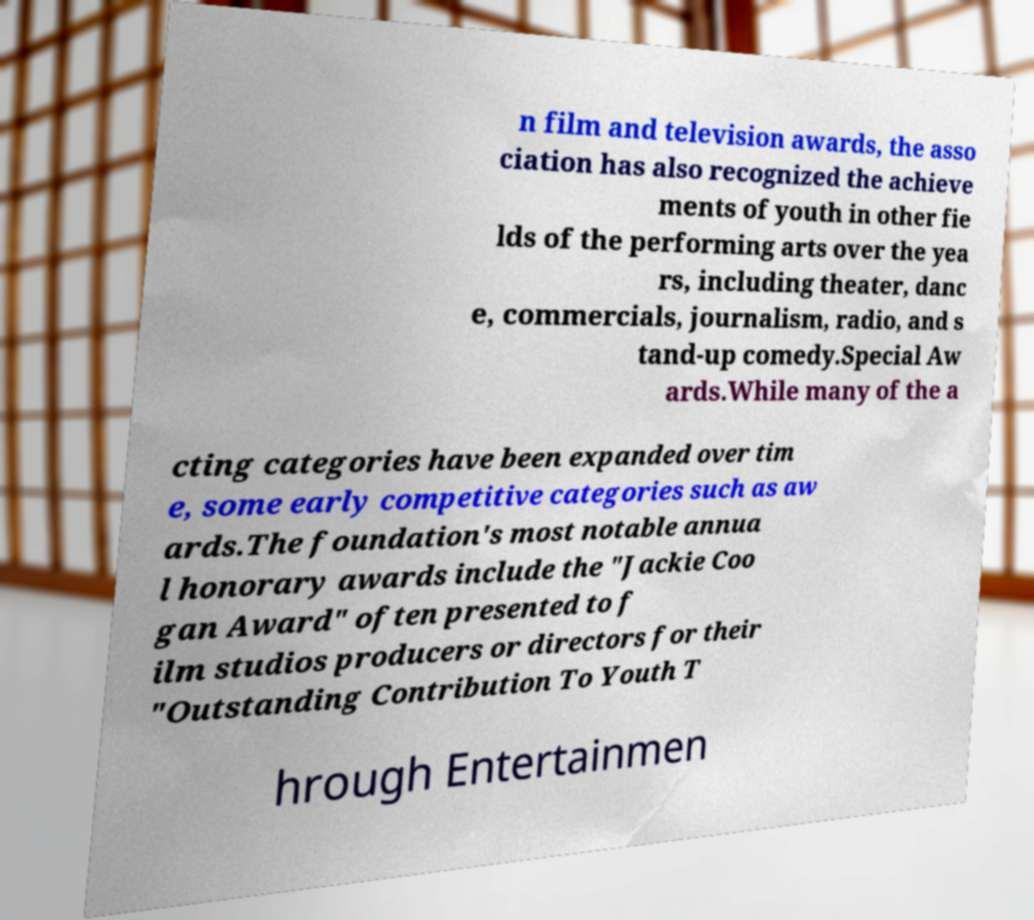Could you assist in decoding the text presented in this image and type it out clearly? n film and television awards, the asso ciation has also recognized the achieve ments of youth in other fie lds of the performing arts over the yea rs, including theater, danc e, commercials, journalism, radio, and s tand-up comedy.Special Aw ards.While many of the a cting categories have been expanded over tim e, some early competitive categories such as aw ards.The foundation's most notable annua l honorary awards include the "Jackie Coo gan Award" often presented to f ilm studios producers or directors for their "Outstanding Contribution To Youth T hrough Entertainmen 